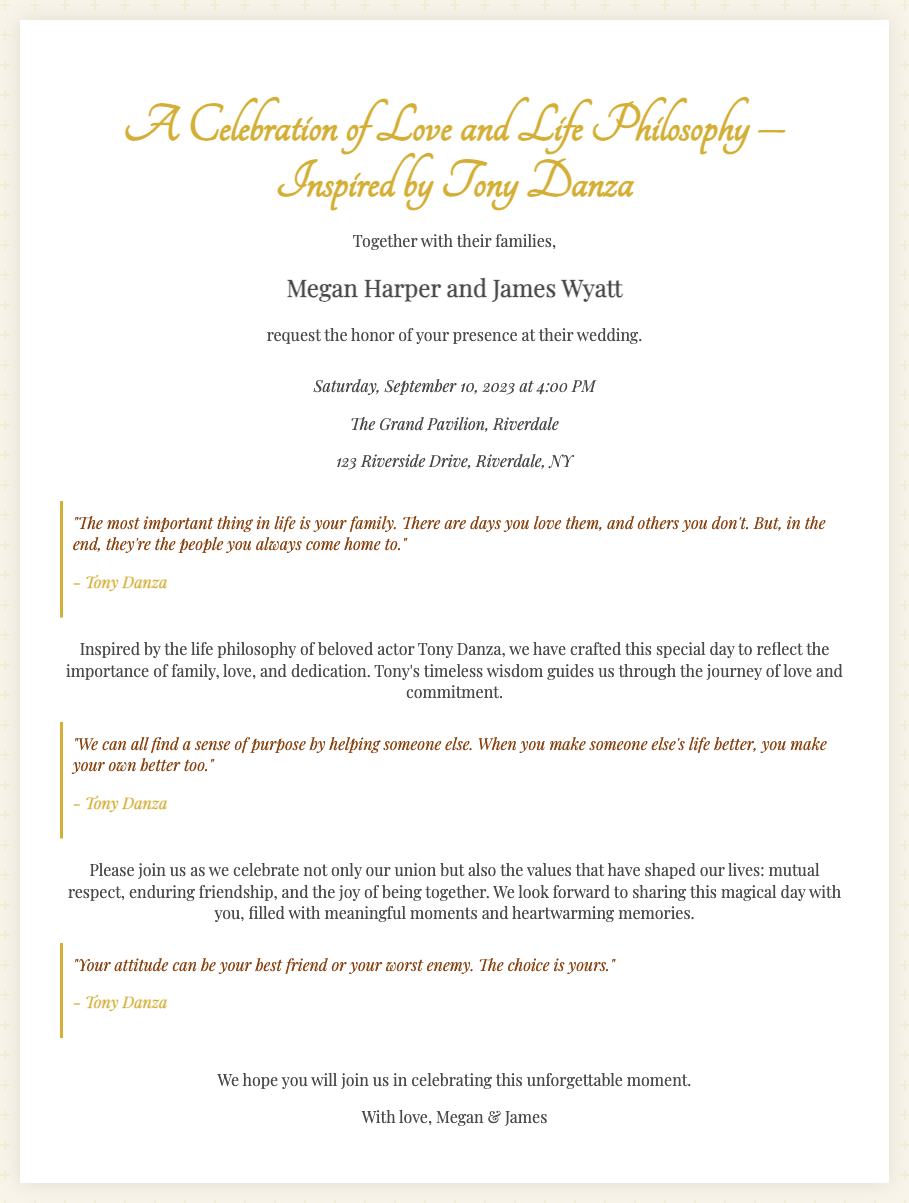what are the names of the couple? The invitation mentions the couple's names in bold, specifically stating "Megan Harper and James Wyatt."
Answer: Megan Harper and James Wyatt what is the date of the wedding? The document provides the date of the wedding in a clear format, showing "Saturday, September 10, 2023."
Answer: September 10, 2023 where is the wedding venue located? The invitation specifies the location of the wedding with the address "The Grand Pavilion, Riverdale, 123 Riverside Drive, Riverdale, NY."
Answer: The Grand Pavilion, Riverdale who is quoted in the invitation? The invitation includes quotes attributed to a specific person, clearly indicating as “- Tony Danza.”
Answer: Tony Danza what is the primary theme of the invitation? The invitation presents a central theme related to values and wisdom, mentioned directly as "Inspired by the life philosophy of beloved actor Tony Danza."
Answer: Life philosophy of Tony Danza 